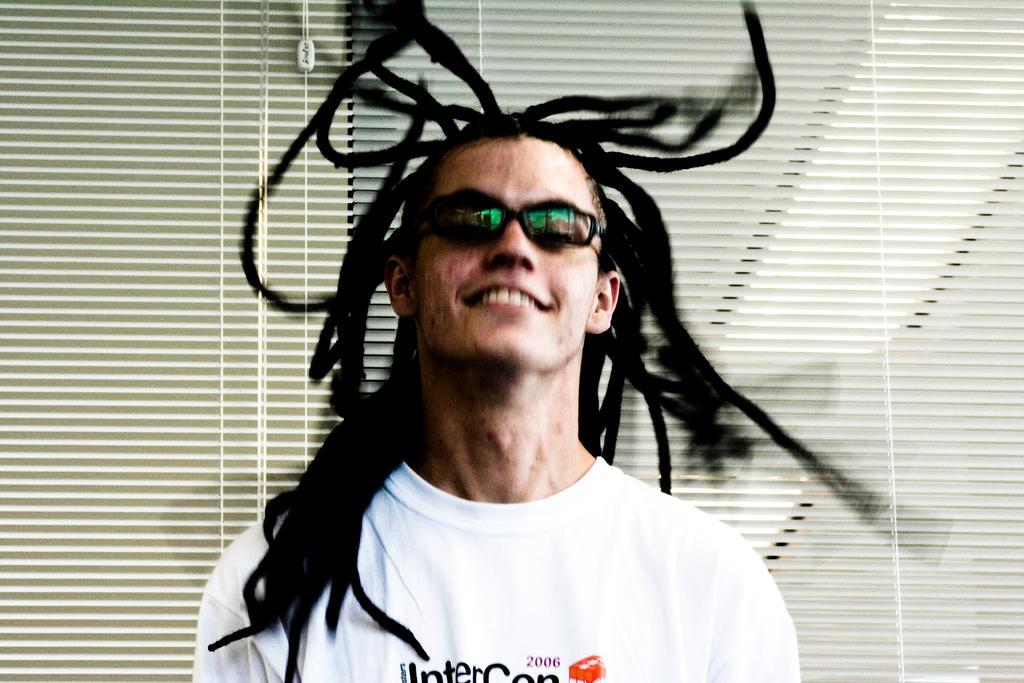Describe this image in one or two sentences. In this image we can see a man and he is smiling. In the background we can see blinds. 